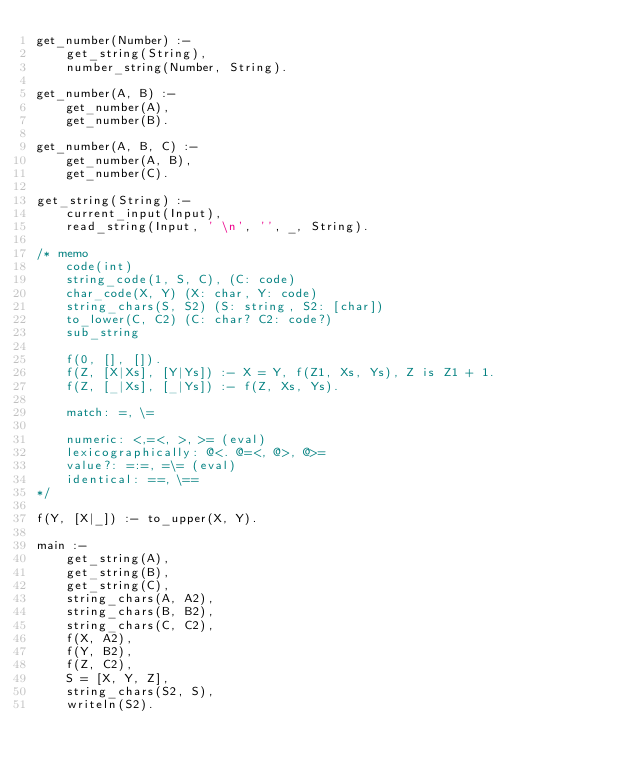<code> <loc_0><loc_0><loc_500><loc_500><_Prolog_>get_number(Number) :-
    get_string(String),
    number_string(Number, String).

get_number(A, B) :-
    get_number(A),
    get_number(B).

get_number(A, B, C) :-
    get_number(A, B),
    get_number(C).

get_string(String) :-
    current_input(Input),
    read_string(Input, ' \n', '', _, String).

/* memo
    code(int)
    string_code(1, S, C), (C: code)
    char_code(X, Y) (X: char, Y: code)
    string_chars(S, S2) (S: string, S2: [char])
    to_lower(C, C2) (C: char? C2: code?)
    sub_string

    f(0, [], []).
    f(Z, [X|Xs], [Y|Ys]) :- X = Y, f(Z1, Xs, Ys), Z is Z1 + 1.
    f(Z, [_|Xs], [_|Ys]) :- f(Z, Xs, Ys).

    match: =, \=

    numeric: <,=<, >, >= (eval)
    lexicographically: @<. @=<, @>, @>=
    value?: =:=, =\= (eval)
    identical: ==, \==
*/

f(Y, [X|_]) :- to_upper(X, Y).

main :-
    get_string(A),
    get_string(B),
    get_string(C),
    string_chars(A, A2),
    string_chars(B, B2),
    string_chars(C, C2),
    f(X, A2),
    f(Y, B2),
    f(Z, C2),
    S = [X, Y, Z],
    string_chars(S2, S),
    writeln(S2).
</code> 